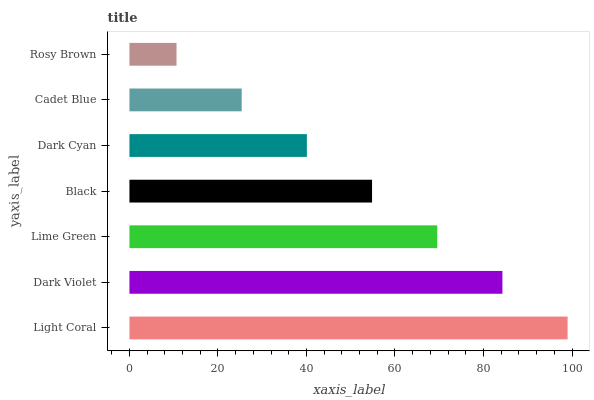Is Rosy Brown the minimum?
Answer yes or no. Yes. Is Light Coral the maximum?
Answer yes or no. Yes. Is Dark Violet the minimum?
Answer yes or no. No. Is Dark Violet the maximum?
Answer yes or no. No. Is Light Coral greater than Dark Violet?
Answer yes or no. Yes. Is Dark Violet less than Light Coral?
Answer yes or no. Yes. Is Dark Violet greater than Light Coral?
Answer yes or no. No. Is Light Coral less than Dark Violet?
Answer yes or no. No. Is Black the high median?
Answer yes or no. Yes. Is Black the low median?
Answer yes or no. Yes. Is Light Coral the high median?
Answer yes or no. No. Is Lime Green the low median?
Answer yes or no. No. 